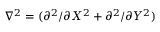<formula> <loc_0><loc_0><loc_500><loc_500>\nabla ^ { 2 } = ( \partial ^ { 2 } / \partial X ^ { 2 } + \partial ^ { 2 } / \partial Y ^ { 2 } )</formula> 